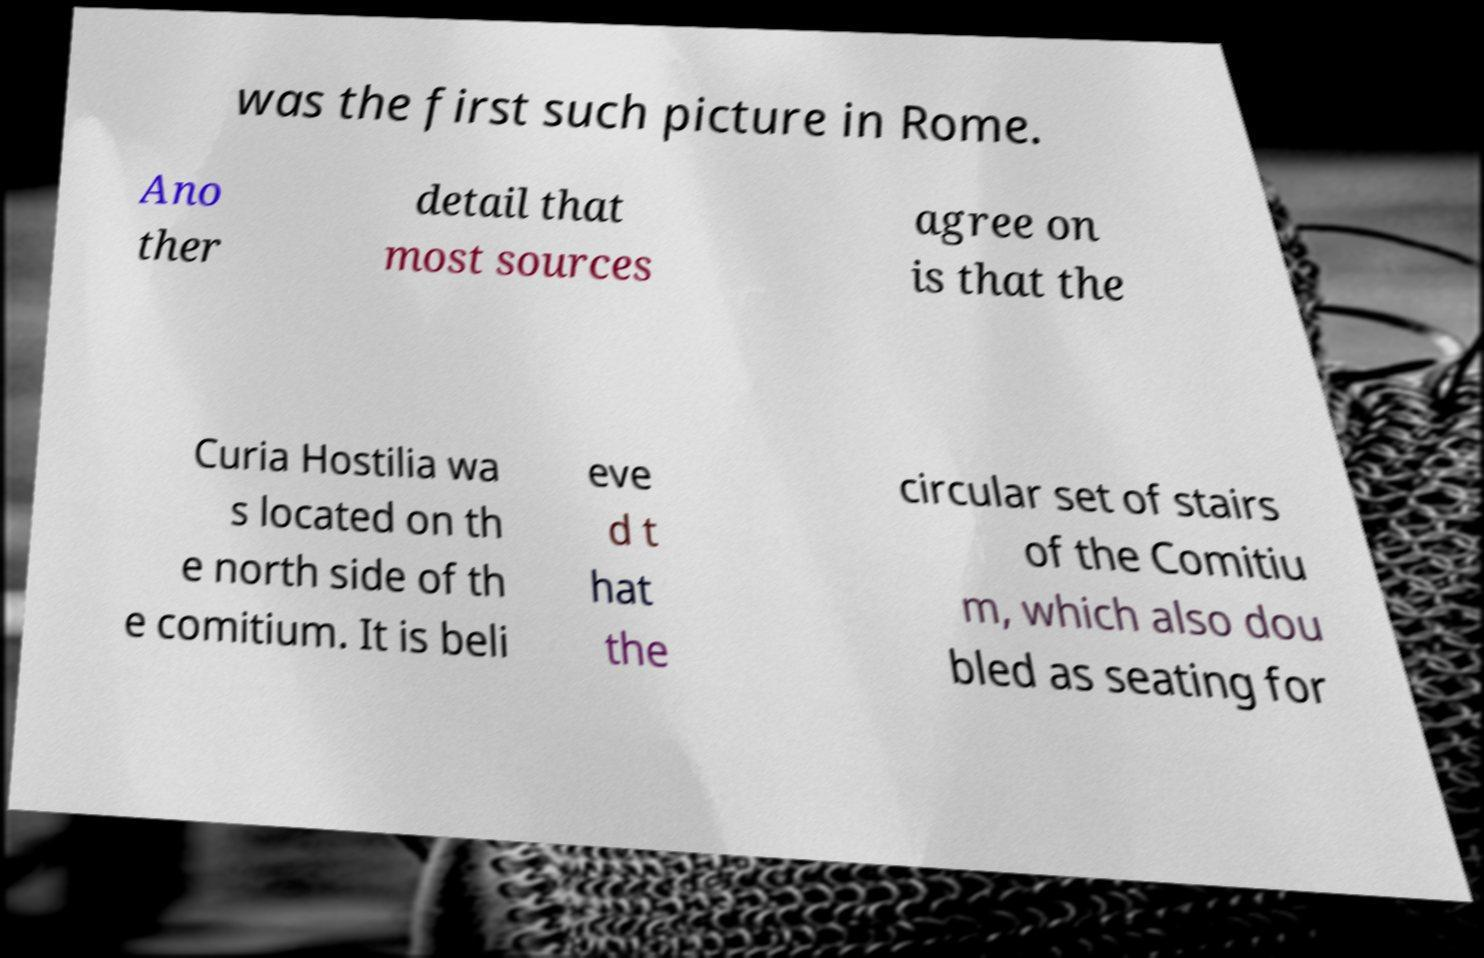Could you extract and type out the text from this image? was the first such picture in Rome. Ano ther detail that most sources agree on is that the Curia Hostilia wa s located on th e north side of th e comitium. It is beli eve d t hat the circular set of stairs of the Comitiu m, which also dou bled as seating for 